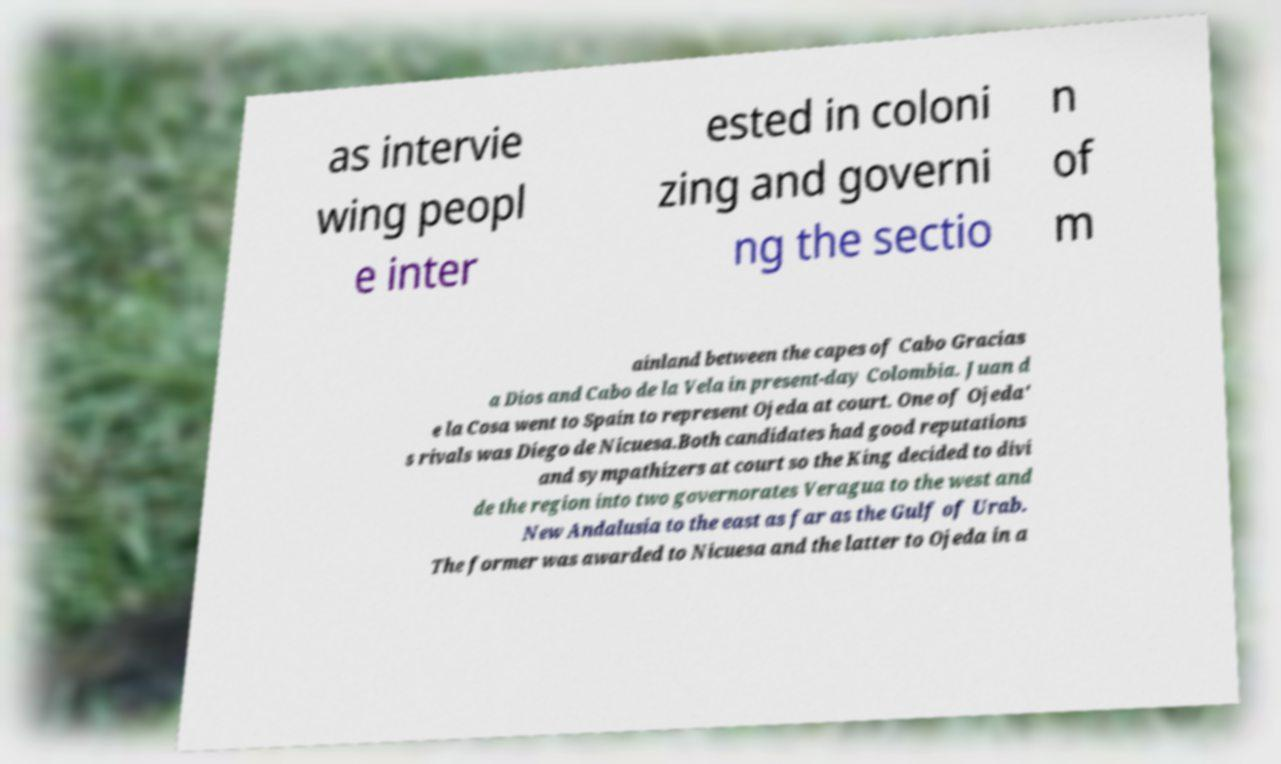Could you assist in decoding the text presented in this image and type it out clearly? as intervie wing peopl e inter ested in coloni zing and governi ng the sectio n of m ainland between the capes of Cabo Gracias a Dios and Cabo de la Vela in present-day Colombia. Juan d e la Cosa went to Spain to represent Ojeda at court. One of Ojeda' s rivals was Diego de Nicuesa.Both candidates had good reputations and sympathizers at court so the King decided to divi de the region into two governorates Veragua to the west and New Andalusia to the east as far as the Gulf of Urab. The former was awarded to Nicuesa and the latter to Ojeda in a 